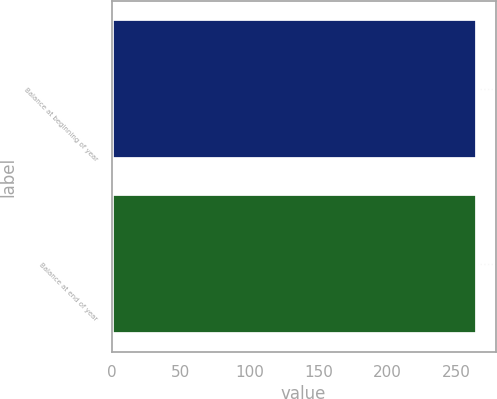<chart> <loc_0><loc_0><loc_500><loc_500><bar_chart><fcel>Balance at beginning of year<fcel>Balance at end of year<nl><fcel>265<fcel>265.1<nl></chart> 